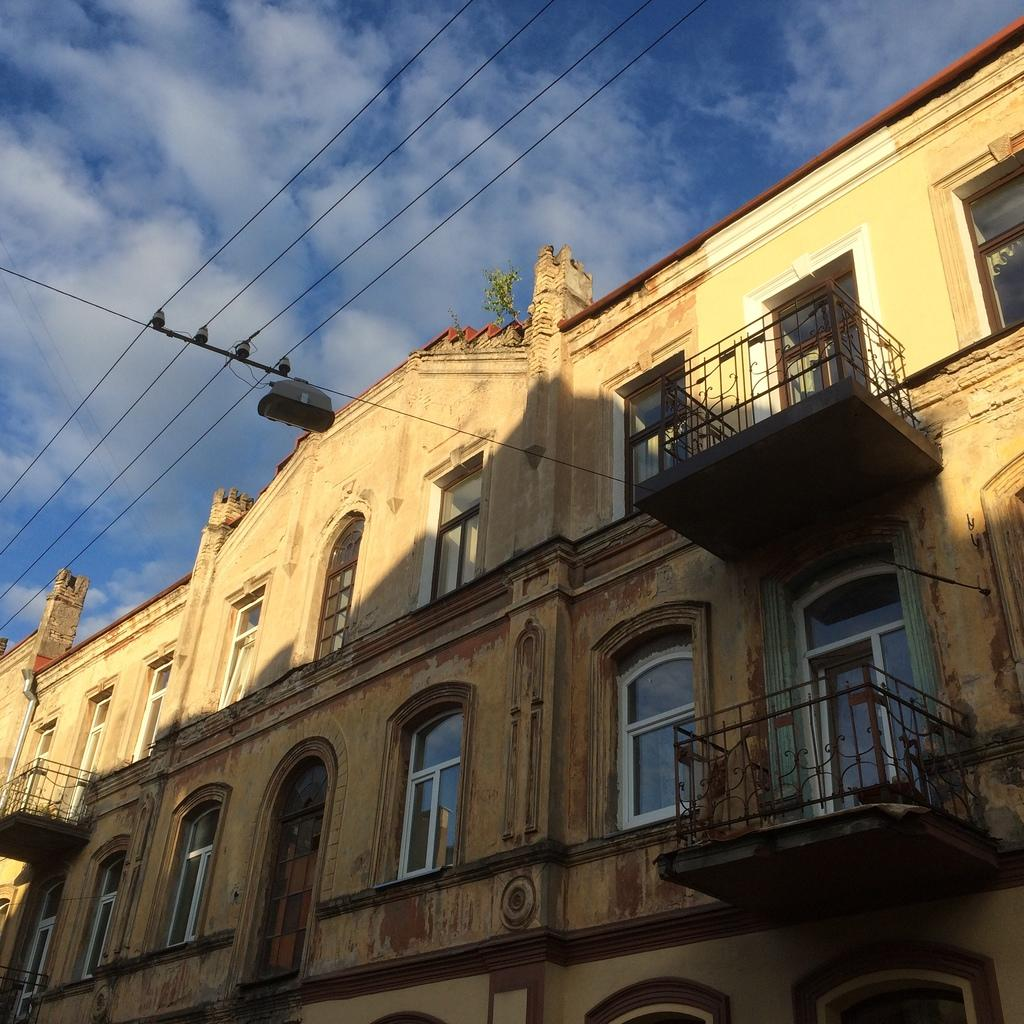What is one of the main elements visible in the image? The sky is one of the main elements visible in the image. What can be seen in the sky in the image? Clouds are present in the image. What type of man-made structures can be seen in the image? Buildings are visible in the image. What part of the buildings can be seen in the image? Windows are present in the image. What type of barriers can be seen in the image? Fences are in the image. What type of natural elements can be seen in the image? Plants are in the image. Can you describe any other objects present in the image? There are a few other objects in the image. Can you see a bone being used as a tool in the image? There is no bone present in the image, so it cannot be used as a tool. Are there any people running in the image? There is no indication of people running in the image. 